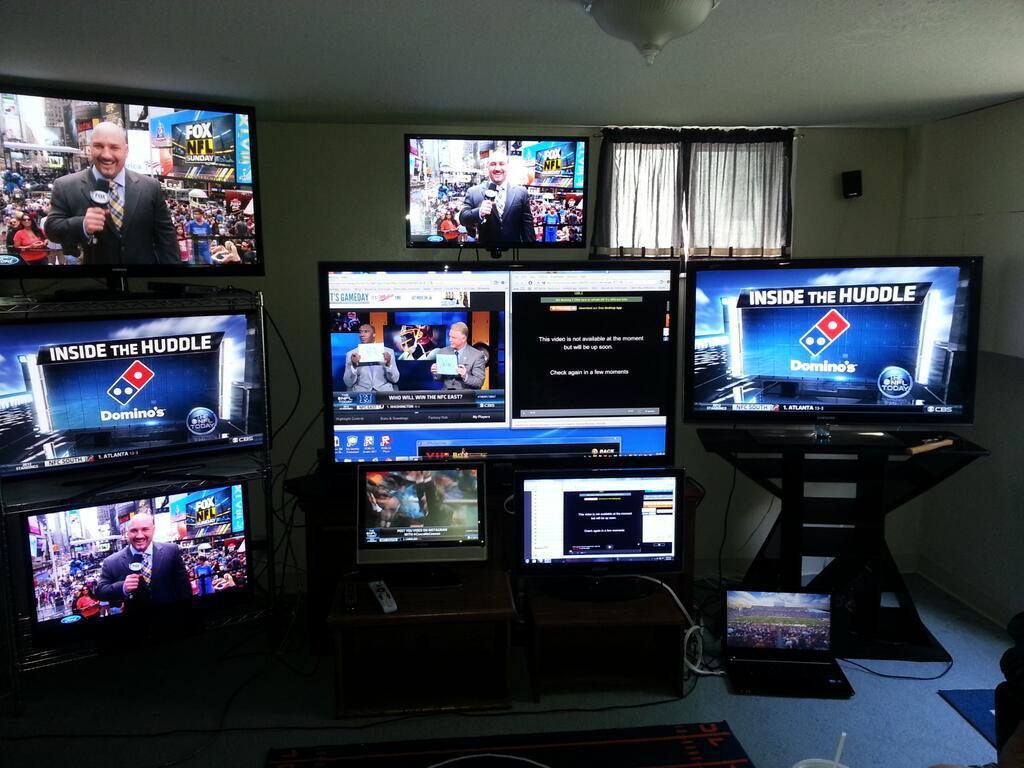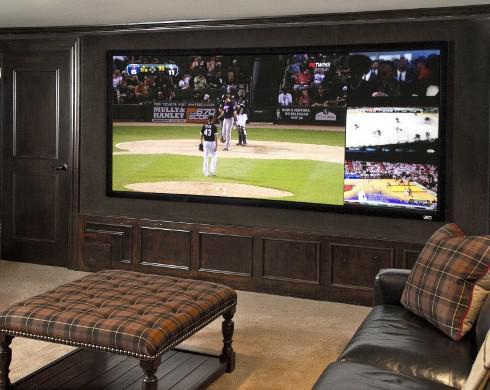The first image is the image on the left, the second image is the image on the right. Assess this claim about the two images: "There are no women featured in any of the images.". Correct or not? Answer yes or no. Yes. 